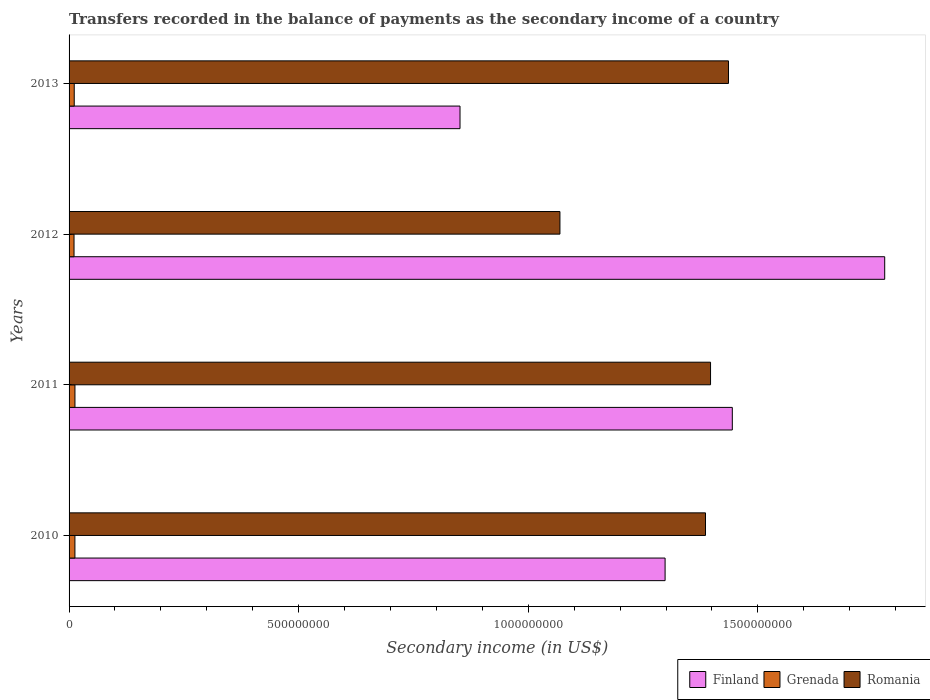How many different coloured bars are there?
Offer a terse response. 3. How many bars are there on the 2nd tick from the bottom?
Make the answer very short. 3. What is the label of the 3rd group of bars from the top?
Your answer should be compact. 2011. In how many cases, is the number of bars for a given year not equal to the number of legend labels?
Offer a very short reply. 0. What is the secondary income of in Grenada in 2013?
Provide a succinct answer. 1.12e+07. Across all years, what is the maximum secondary income of in Grenada?
Make the answer very short. 1.28e+07. Across all years, what is the minimum secondary income of in Finland?
Make the answer very short. 8.51e+08. In which year was the secondary income of in Grenada maximum?
Offer a very short reply. 2011. In which year was the secondary income of in Romania minimum?
Offer a terse response. 2012. What is the total secondary income of in Grenada in the graph?
Offer a very short reply. 4.76e+07. What is the difference between the secondary income of in Grenada in 2012 and that in 2013?
Provide a succinct answer. -4.39e+05. What is the difference between the secondary income of in Grenada in 2011 and the secondary income of in Finland in 2012?
Make the answer very short. -1.76e+09. What is the average secondary income of in Romania per year?
Ensure brevity in your answer.  1.32e+09. In the year 2011, what is the difference between the secondary income of in Finland and secondary income of in Grenada?
Give a very brief answer. 1.43e+09. What is the ratio of the secondary income of in Romania in 2010 to that in 2013?
Make the answer very short. 0.97. Is the difference between the secondary income of in Finland in 2011 and 2013 greater than the difference between the secondary income of in Grenada in 2011 and 2013?
Keep it short and to the point. Yes. What is the difference between the highest and the second highest secondary income of in Grenada?
Offer a very short reply. 7.81e+04. What is the difference between the highest and the lowest secondary income of in Grenada?
Make the answer very short. 2.02e+06. In how many years, is the secondary income of in Grenada greater than the average secondary income of in Grenada taken over all years?
Ensure brevity in your answer.  2. Is the sum of the secondary income of in Grenada in 2011 and 2013 greater than the maximum secondary income of in Romania across all years?
Offer a very short reply. No. What does the 1st bar from the top in 2012 represents?
Your answer should be very brief. Romania. What does the 1st bar from the bottom in 2012 represents?
Provide a short and direct response. Finland. Is it the case that in every year, the sum of the secondary income of in Grenada and secondary income of in Finland is greater than the secondary income of in Romania?
Provide a short and direct response. No. How many bars are there?
Your answer should be compact. 12. Does the graph contain grids?
Your answer should be very brief. No. How many legend labels are there?
Make the answer very short. 3. How are the legend labels stacked?
Give a very brief answer. Horizontal. What is the title of the graph?
Provide a succinct answer. Transfers recorded in the balance of payments as the secondary income of a country. Does "Sri Lanka" appear as one of the legend labels in the graph?
Provide a succinct answer. No. What is the label or title of the X-axis?
Make the answer very short. Secondary income (in US$). What is the label or title of the Y-axis?
Provide a succinct answer. Years. What is the Secondary income (in US$) of Finland in 2010?
Your response must be concise. 1.30e+09. What is the Secondary income (in US$) in Grenada in 2010?
Offer a very short reply. 1.27e+07. What is the Secondary income (in US$) of Romania in 2010?
Ensure brevity in your answer.  1.39e+09. What is the Secondary income (in US$) of Finland in 2011?
Keep it short and to the point. 1.44e+09. What is the Secondary income (in US$) in Grenada in 2011?
Provide a short and direct response. 1.28e+07. What is the Secondary income (in US$) of Romania in 2011?
Give a very brief answer. 1.40e+09. What is the Secondary income (in US$) of Finland in 2012?
Offer a terse response. 1.78e+09. What is the Secondary income (in US$) of Grenada in 2012?
Offer a very short reply. 1.08e+07. What is the Secondary income (in US$) of Romania in 2012?
Provide a succinct answer. 1.07e+09. What is the Secondary income (in US$) of Finland in 2013?
Provide a succinct answer. 8.51e+08. What is the Secondary income (in US$) in Grenada in 2013?
Your answer should be very brief. 1.12e+07. What is the Secondary income (in US$) of Romania in 2013?
Offer a very short reply. 1.44e+09. Across all years, what is the maximum Secondary income (in US$) in Finland?
Your answer should be very brief. 1.78e+09. Across all years, what is the maximum Secondary income (in US$) of Grenada?
Your answer should be very brief. 1.28e+07. Across all years, what is the maximum Secondary income (in US$) of Romania?
Offer a terse response. 1.44e+09. Across all years, what is the minimum Secondary income (in US$) in Finland?
Make the answer very short. 8.51e+08. Across all years, what is the minimum Secondary income (in US$) in Grenada?
Provide a short and direct response. 1.08e+07. Across all years, what is the minimum Secondary income (in US$) in Romania?
Make the answer very short. 1.07e+09. What is the total Secondary income (in US$) of Finland in the graph?
Provide a short and direct response. 5.37e+09. What is the total Secondary income (in US$) of Grenada in the graph?
Keep it short and to the point. 4.76e+07. What is the total Secondary income (in US$) of Romania in the graph?
Ensure brevity in your answer.  5.29e+09. What is the difference between the Secondary income (in US$) of Finland in 2010 and that in 2011?
Provide a short and direct response. -1.46e+08. What is the difference between the Secondary income (in US$) of Grenada in 2010 and that in 2011?
Give a very brief answer. -7.81e+04. What is the difference between the Secondary income (in US$) of Romania in 2010 and that in 2011?
Keep it short and to the point. -1.10e+07. What is the difference between the Secondary income (in US$) of Finland in 2010 and that in 2012?
Your response must be concise. -4.78e+08. What is the difference between the Secondary income (in US$) of Grenada in 2010 and that in 2012?
Provide a succinct answer. 1.94e+06. What is the difference between the Secondary income (in US$) in Romania in 2010 and that in 2012?
Give a very brief answer. 3.17e+08. What is the difference between the Secondary income (in US$) in Finland in 2010 and that in 2013?
Provide a succinct answer. 4.47e+08. What is the difference between the Secondary income (in US$) of Grenada in 2010 and that in 2013?
Ensure brevity in your answer.  1.50e+06. What is the difference between the Secondary income (in US$) of Romania in 2010 and that in 2013?
Offer a terse response. -5.00e+07. What is the difference between the Secondary income (in US$) of Finland in 2011 and that in 2012?
Make the answer very short. -3.32e+08. What is the difference between the Secondary income (in US$) of Grenada in 2011 and that in 2012?
Offer a terse response. 2.02e+06. What is the difference between the Secondary income (in US$) of Romania in 2011 and that in 2012?
Make the answer very short. 3.28e+08. What is the difference between the Secondary income (in US$) in Finland in 2011 and that in 2013?
Offer a terse response. 5.93e+08. What is the difference between the Secondary income (in US$) in Grenada in 2011 and that in 2013?
Provide a succinct answer. 1.58e+06. What is the difference between the Secondary income (in US$) of Romania in 2011 and that in 2013?
Your response must be concise. -3.90e+07. What is the difference between the Secondary income (in US$) in Finland in 2012 and that in 2013?
Make the answer very short. 9.25e+08. What is the difference between the Secondary income (in US$) of Grenada in 2012 and that in 2013?
Offer a terse response. -4.39e+05. What is the difference between the Secondary income (in US$) of Romania in 2012 and that in 2013?
Ensure brevity in your answer.  -3.67e+08. What is the difference between the Secondary income (in US$) in Finland in 2010 and the Secondary income (in US$) in Grenada in 2011?
Provide a short and direct response. 1.29e+09. What is the difference between the Secondary income (in US$) of Finland in 2010 and the Secondary income (in US$) of Romania in 2011?
Provide a succinct answer. -9.90e+07. What is the difference between the Secondary income (in US$) in Grenada in 2010 and the Secondary income (in US$) in Romania in 2011?
Give a very brief answer. -1.38e+09. What is the difference between the Secondary income (in US$) in Finland in 2010 and the Secondary income (in US$) in Grenada in 2012?
Keep it short and to the point. 1.29e+09. What is the difference between the Secondary income (in US$) of Finland in 2010 and the Secondary income (in US$) of Romania in 2012?
Provide a succinct answer. 2.29e+08. What is the difference between the Secondary income (in US$) of Grenada in 2010 and the Secondary income (in US$) of Romania in 2012?
Make the answer very short. -1.06e+09. What is the difference between the Secondary income (in US$) in Finland in 2010 and the Secondary income (in US$) in Grenada in 2013?
Your response must be concise. 1.29e+09. What is the difference between the Secondary income (in US$) in Finland in 2010 and the Secondary income (in US$) in Romania in 2013?
Provide a short and direct response. -1.38e+08. What is the difference between the Secondary income (in US$) of Grenada in 2010 and the Secondary income (in US$) of Romania in 2013?
Make the answer very short. -1.42e+09. What is the difference between the Secondary income (in US$) of Finland in 2011 and the Secondary income (in US$) of Grenada in 2012?
Offer a very short reply. 1.43e+09. What is the difference between the Secondary income (in US$) in Finland in 2011 and the Secondary income (in US$) in Romania in 2012?
Provide a succinct answer. 3.75e+08. What is the difference between the Secondary income (in US$) in Grenada in 2011 and the Secondary income (in US$) in Romania in 2012?
Your answer should be compact. -1.06e+09. What is the difference between the Secondary income (in US$) in Finland in 2011 and the Secondary income (in US$) in Grenada in 2013?
Your answer should be compact. 1.43e+09. What is the difference between the Secondary income (in US$) of Finland in 2011 and the Secondary income (in US$) of Romania in 2013?
Offer a terse response. 8.36e+06. What is the difference between the Secondary income (in US$) of Grenada in 2011 and the Secondary income (in US$) of Romania in 2013?
Provide a short and direct response. -1.42e+09. What is the difference between the Secondary income (in US$) of Finland in 2012 and the Secondary income (in US$) of Grenada in 2013?
Give a very brief answer. 1.77e+09. What is the difference between the Secondary income (in US$) of Finland in 2012 and the Secondary income (in US$) of Romania in 2013?
Give a very brief answer. 3.40e+08. What is the difference between the Secondary income (in US$) of Grenada in 2012 and the Secondary income (in US$) of Romania in 2013?
Ensure brevity in your answer.  -1.43e+09. What is the average Secondary income (in US$) of Finland per year?
Offer a terse response. 1.34e+09. What is the average Secondary income (in US$) in Grenada per year?
Make the answer very short. 1.19e+07. What is the average Secondary income (in US$) of Romania per year?
Offer a very short reply. 1.32e+09. In the year 2010, what is the difference between the Secondary income (in US$) in Finland and Secondary income (in US$) in Grenada?
Provide a short and direct response. 1.29e+09. In the year 2010, what is the difference between the Secondary income (in US$) in Finland and Secondary income (in US$) in Romania?
Provide a short and direct response. -8.80e+07. In the year 2010, what is the difference between the Secondary income (in US$) in Grenada and Secondary income (in US$) in Romania?
Your answer should be very brief. -1.37e+09. In the year 2011, what is the difference between the Secondary income (in US$) in Finland and Secondary income (in US$) in Grenada?
Offer a very short reply. 1.43e+09. In the year 2011, what is the difference between the Secondary income (in US$) of Finland and Secondary income (in US$) of Romania?
Your answer should be compact. 4.74e+07. In the year 2011, what is the difference between the Secondary income (in US$) in Grenada and Secondary income (in US$) in Romania?
Make the answer very short. -1.38e+09. In the year 2012, what is the difference between the Secondary income (in US$) of Finland and Secondary income (in US$) of Grenada?
Provide a short and direct response. 1.77e+09. In the year 2012, what is the difference between the Secondary income (in US$) in Finland and Secondary income (in US$) in Romania?
Your response must be concise. 7.07e+08. In the year 2012, what is the difference between the Secondary income (in US$) in Grenada and Secondary income (in US$) in Romania?
Offer a very short reply. -1.06e+09. In the year 2013, what is the difference between the Secondary income (in US$) in Finland and Secondary income (in US$) in Grenada?
Offer a very short reply. 8.40e+08. In the year 2013, what is the difference between the Secondary income (in US$) of Finland and Secondary income (in US$) of Romania?
Provide a short and direct response. -5.85e+08. In the year 2013, what is the difference between the Secondary income (in US$) in Grenada and Secondary income (in US$) in Romania?
Keep it short and to the point. -1.42e+09. What is the ratio of the Secondary income (in US$) in Finland in 2010 to that in 2011?
Your answer should be very brief. 0.9. What is the ratio of the Secondary income (in US$) in Finland in 2010 to that in 2012?
Your response must be concise. 0.73. What is the ratio of the Secondary income (in US$) of Grenada in 2010 to that in 2012?
Give a very brief answer. 1.18. What is the ratio of the Secondary income (in US$) of Romania in 2010 to that in 2012?
Provide a short and direct response. 1.3. What is the ratio of the Secondary income (in US$) in Finland in 2010 to that in 2013?
Provide a succinct answer. 1.52. What is the ratio of the Secondary income (in US$) of Grenada in 2010 to that in 2013?
Make the answer very short. 1.13. What is the ratio of the Secondary income (in US$) of Romania in 2010 to that in 2013?
Give a very brief answer. 0.97. What is the ratio of the Secondary income (in US$) in Finland in 2011 to that in 2012?
Keep it short and to the point. 0.81. What is the ratio of the Secondary income (in US$) in Grenada in 2011 to that in 2012?
Your answer should be compact. 1.19. What is the ratio of the Secondary income (in US$) of Romania in 2011 to that in 2012?
Make the answer very short. 1.31. What is the ratio of the Secondary income (in US$) in Finland in 2011 to that in 2013?
Provide a short and direct response. 1.7. What is the ratio of the Secondary income (in US$) of Grenada in 2011 to that in 2013?
Your answer should be very brief. 1.14. What is the ratio of the Secondary income (in US$) of Romania in 2011 to that in 2013?
Offer a terse response. 0.97. What is the ratio of the Secondary income (in US$) in Finland in 2012 to that in 2013?
Provide a short and direct response. 2.09. What is the ratio of the Secondary income (in US$) of Grenada in 2012 to that in 2013?
Your answer should be compact. 0.96. What is the ratio of the Secondary income (in US$) in Romania in 2012 to that in 2013?
Provide a succinct answer. 0.74. What is the difference between the highest and the second highest Secondary income (in US$) in Finland?
Provide a short and direct response. 3.32e+08. What is the difference between the highest and the second highest Secondary income (in US$) in Grenada?
Offer a very short reply. 7.81e+04. What is the difference between the highest and the second highest Secondary income (in US$) of Romania?
Ensure brevity in your answer.  3.90e+07. What is the difference between the highest and the lowest Secondary income (in US$) of Finland?
Give a very brief answer. 9.25e+08. What is the difference between the highest and the lowest Secondary income (in US$) of Grenada?
Provide a short and direct response. 2.02e+06. What is the difference between the highest and the lowest Secondary income (in US$) in Romania?
Give a very brief answer. 3.67e+08. 